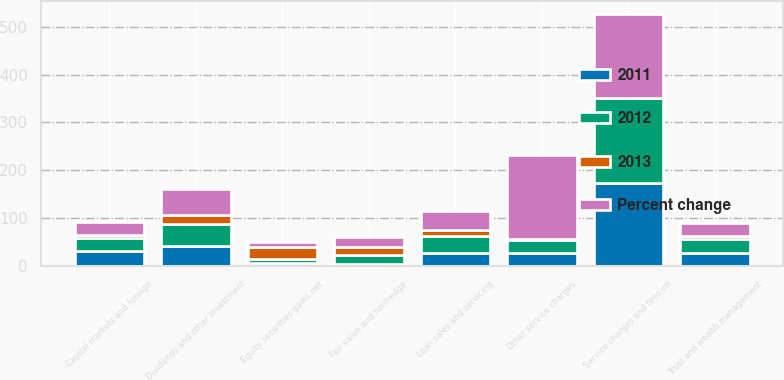Convert chart to OTSL. <chart><loc_0><loc_0><loc_500><loc_500><stacked_bar_chart><ecel><fcel>Service charges and fees on<fcel>Other service charges<fcel>Trust and wealth management<fcel>Capital markets and foreign<fcel>Dividends and other investment<fcel>Loan sales and servicing<fcel>Fair value and nonhedge<fcel>Equity securities gains net<nl><fcel>2012<fcel>176.3<fcel>26.75<fcel>29.9<fcel>28.1<fcel>46.1<fcel>35.3<fcel>18.2<fcel>8.5<nl><fcel>2013<fcel>0.1<fcel>4.1<fcel>5.3<fcel>4.9<fcel>17.4<fcel>11.8<fcel>16.5<fcel>24.8<nl><fcel>Percent change<fcel>176.4<fcel>174.4<fcel>28.4<fcel>26.8<fcel>55.8<fcel>40<fcel>21.8<fcel>11.3<nl><fcel>2011<fcel>174.4<fcel>26.75<fcel>26.7<fcel>31.4<fcel>42.4<fcel>28.1<fcel>5<fcel>6.5<nl></chart> 